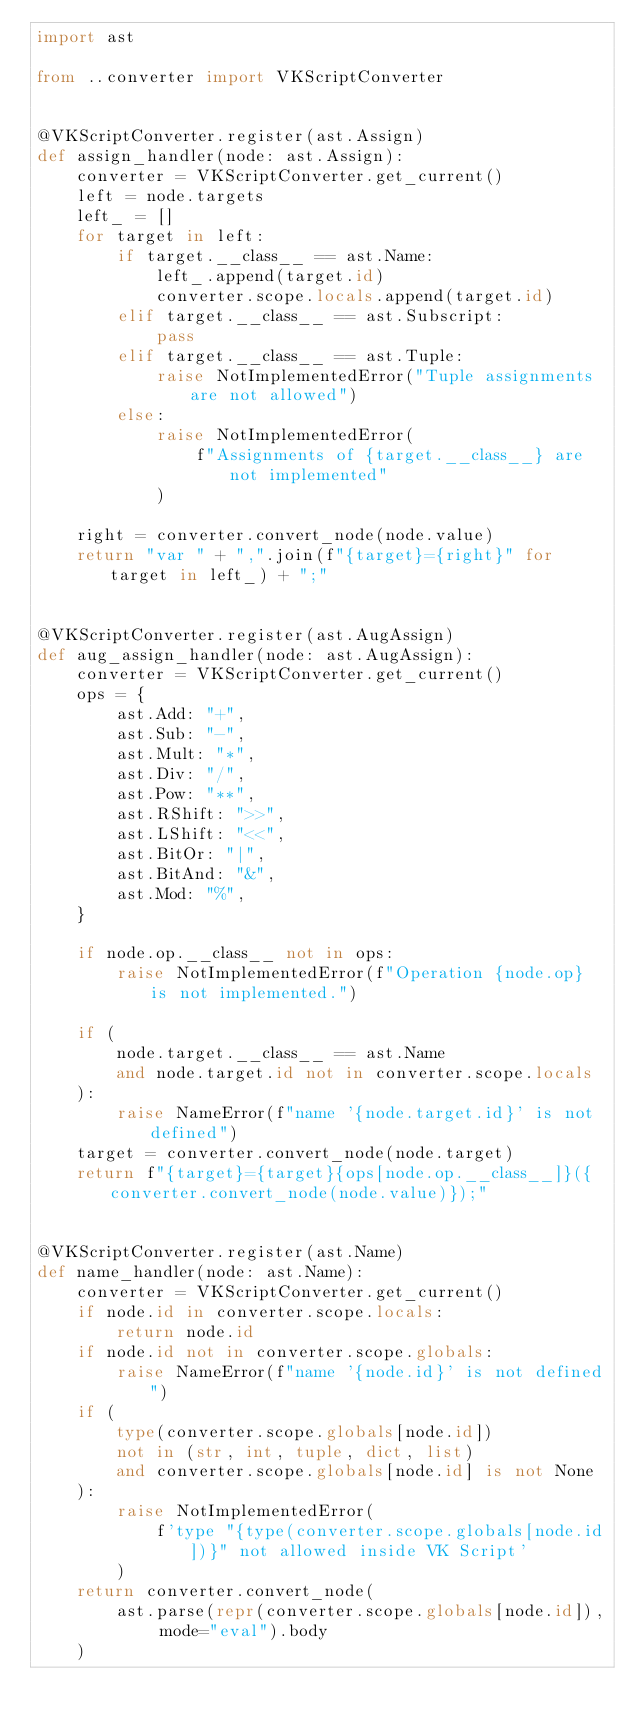<code> <loc_0><loc_0><loc_500><loc_500><_Python_>import ast

from ..converter import VKScriptConverter


@VKScriptConverter.register(ast.Assign)
def assign_handler(node: ast.Assign):
    converter = VKScriptConverter.get_current()
    left = node.targets
    left_ = []
    for target in left:
        if target.__class__ == ast.Name:
            left_.append(target.id)
            converter.scope.locals.append(target.id)
        elif target.__class__ == ast.Subscript:
            pass
        elif target.__class__ == ast.Tuple:
            raise NotImplementedError("Tuple assignments are not allowed")
        else:
            raise NotImplementedError(
                f"Assignments of {target.__class__} are not implemented"
            )

    right = converter.convert_node(node.value)
    return "var " + ",".join(f"{target}={right}" for target in left_) + ";"


@VKScriptConverter.register(ast.AugAssign)
def aug_assign_handler(node: ast.AugAssign):
    converter = VKScriptConverter.get_current()
    ops = {
        ast.Add: "+",
        ast.Sub: "-",
        ast.Mult: "*",
        ast.Div: "/",
        ast.Pow: "**",
        ast.RShift: ">>",
        ast.LShift: "<<",
        ast.BitOr: "|",
        ast.BitAnd: "&",
        ast.Mod: "%",
    }

    if node.op.__class__ not in ops:
        raise NotImplementedError(f"Operation {node.op} is not implemented.")

    if (
        node.target.__class__ == ast.Name
        and node.target.id not in converter.scope.locals
    ):
        raise NameError(f"name '{node.target.id}' is not defined")
    target = converter.convert_node(node.target)
    return f"{target}={target}{ops[node.op.__class__]}({converter.convert_node(node.value)});"


@VKScriptConverter.register(ast.Name)
def name_handler(node: ast.Name):
    converter = VKScriptConverter.get_current()
    if node.id in converter.scope.locals:
        return node.id
    if node.id not in converter.scope.globals:
        raise NameError(f"name '{node.id}' is not defined")
    if (
        type(converter.scope.globals[node.id])
        not in (str, int, tuple, dict, list)
        and converter.scope.globals[node.id] is not None
    ):
        raise NotImplementedError(
            f'type "{type(converter.scope.globals[node.id])}" not allowed inside VK Script'
        )
    return converter.convert_node(
        ast.parse(repr(converter.scope.globals[node.id]), mode="eval").body
    )
</code> 